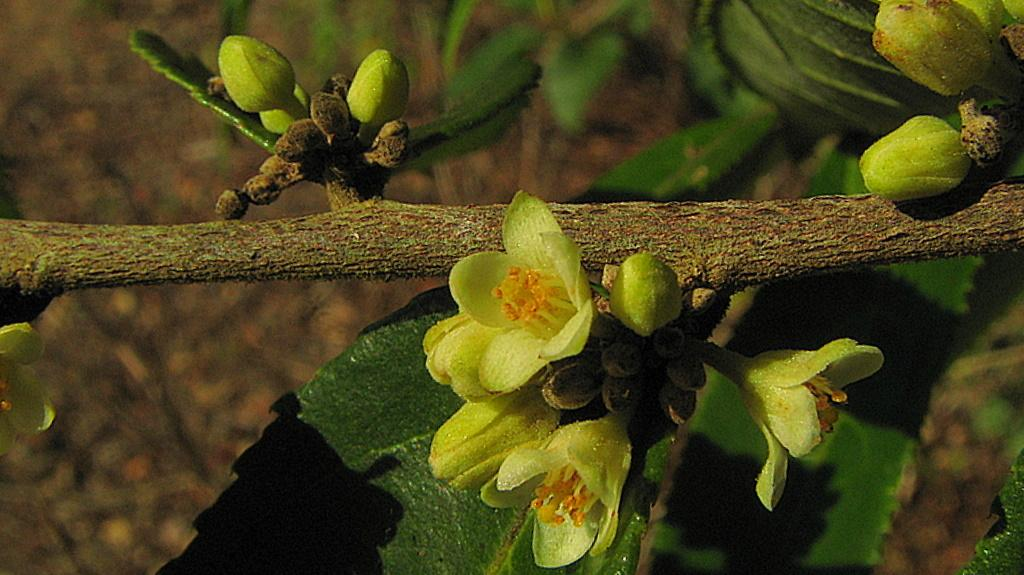What type of plant life is visible in the image? There are flowers, buds, and leaves in the image. How are the leaves connected to the rest of the plant? The leaves are attached to a stem. What is the overall appearance of the background in the image? The background in the image is blurred. What month is it in the image? The month cannot be determined from the image, as it does not contain any information about the time of year. 